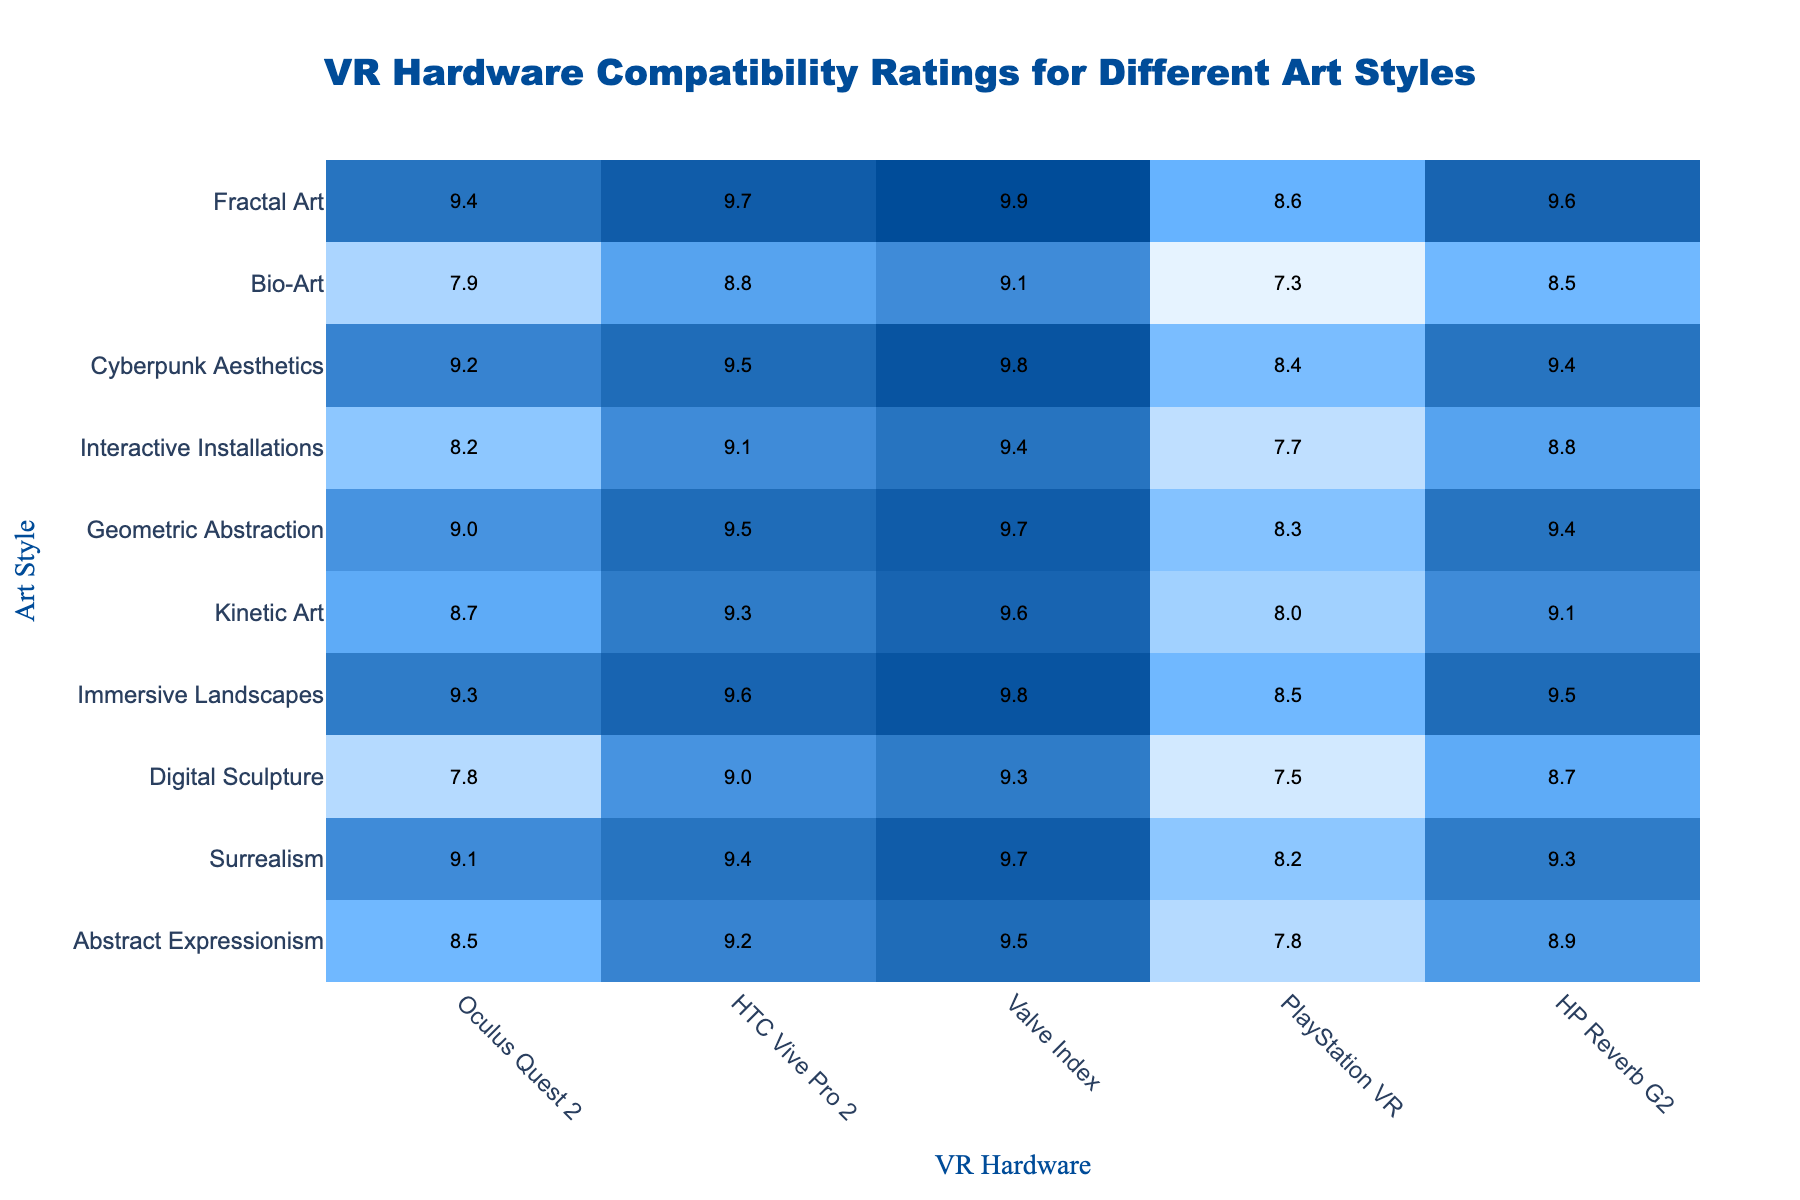What is the VR hardware with the highest compatibility rating for Abstract Expressionism? The highest compatibility rating for Abstract Expressionism is 9.5, which corresponds to the Valve Index.
Answer: Valve Index Which art style has the lowest compatibility rating on the Oculus Quest 2? Digital Sculpture has the lowest compatibility rating on the Oculus Quest 2, with a score of 7.8.
Answer: Digital Sculpture What is the average compatibility rating for Surrealism across all VR hardware? The compatibility ratings for Surrealism are 9.1, 9.4, 9.7, 8.2, and 9.3. Summing these gives 45.4. Dividing by 5 gives an average of 9.08.
Answer: 9.08 Is the compatibility rating for Cyberpunk Aesthetics higher than that of Digital Sculpture on the Valve Index? Cyberpunk Aesthetics has a rating of 9.8 on the Valve Index while Digital Sculpture has a rating of 9.3. Since 9.8 is greater than 9.3, the statement is true.
Answer: Yes Which art style has the most consistent ratings across all VR hardware, judging by the range of scores? The range for each art style can be calculated. The smallest range is for Bio-Art, which has scores ranging from 7.3 to 9.1, giving a range of 1.8. All other art styles have higher ranges.
Answer: Bio-Art How many art styles have an average rating above 9.0 on the HTC Vive Pro 2? The ratings for HTC Vive Pro 2 are: 9.2, 9.4, 9.0, 9.6, 9.3, 9.5, 9.1, 9.5, 8.8, and 9.7. Five out of these ten ratings are above 9.0.
Answer: Five Which VR hardware has the highest compatibility rating for Immersive Landscapes? Immersive Landscapes has a compatibility rating of 9.8 on the Valve Index, which is the highest rating compared to other VR hardware.
Answer: Valve Index What is the difference in compatibility ratings for Geometric Abstraction between the Valve Index and PlayStation VR? The rating for Geometric Abstraction on the Valve Index is 9.7, and on PlayStation VR is 8.3. The difference is 9.7 - 8.3 = 1.4.
Answer: 1.4 Is Kinetic Art more compatible with the HP Reverb G2 than with the HTC Vive Pro 2? Kinetic Art has a rating of 9.1 on the HP Reverb G2 and 9.3 on the HTC Vive Pro 2. Since 9.1 is less than 9.3, the statement is false.
Answer: No What art style shows the least amount of compatibility with PlayStation VR, and what is its rating? The art style with the least compatibility rating on PlayStation VR is Bio-Art, with a score of 7.3.
Answer: Bio-Art, 7.3 